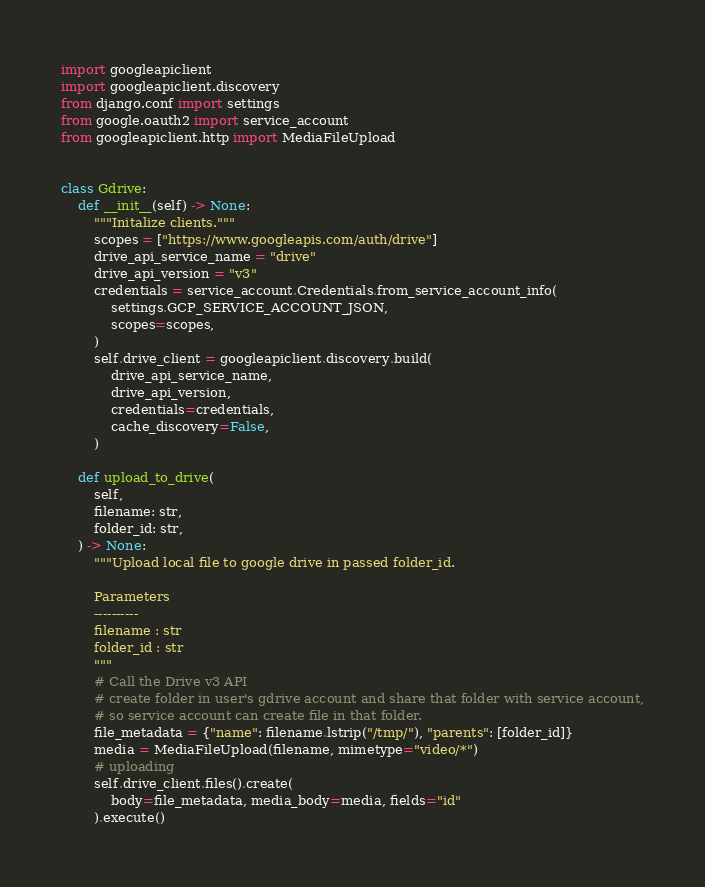<code> <loc_0><loc_0><loc_500><loc_500><_Python_>import googleapiclient
import googleapiclient.discovery
from django.conf import settings
from google.oauth2 import service_account
from googleapiclient.http import MediaFileUpload


class Gdrive:
    def __init__(self) -> None:
        """Initalize clients."""
        scopes = ["https://www.googleapis.com/auth/drive"]
        drive_api_service_name = "drive"
        drive_api_version = "v3"
        credentials = service_account.Credentials.from_service_account_info(
            settings.GCP_SERVICE_ACCOUNT_JSON,
            scopes=scopes,
        )
        self.drive_client = googleapiclient.discovery.build(
            drive_api_service_name,
            drive_api_version,
            credentials=credentials,
            cache_discovery=False,
        )

    def upload_to_drive(
        self,
        filename: str,
        folder_id: str,
    ) -> None:
        """Upload local file to google drive in passed folder_id.

        Parameters
        ----------
        filename : str
        folder_id : str
        """
        # Call the Drive v3 API
        # create folder in user's gdrive account and share that folder with service account,
        # so service account can create file in that folder.
        file_metadata = {"name": filename.lstrip("/tmp/"), "parents": [folder_id]}
        media = MediaFileUpload(filename, mimetype="video/*")
        # uploading
        self.drive_client.files().create(
            body=file_metadata, media_body=media, fields="id"
        ).execute()
</code> 